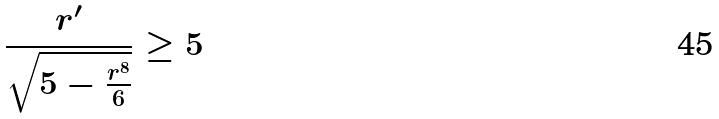<formula> <loc_0><loc_0><loc_500><loc_500>\frac { r ^ { \prime } } { \sqrt { 5 - \frac { r ^ { 8 } } { 6 } } } \geq 5</formula> 